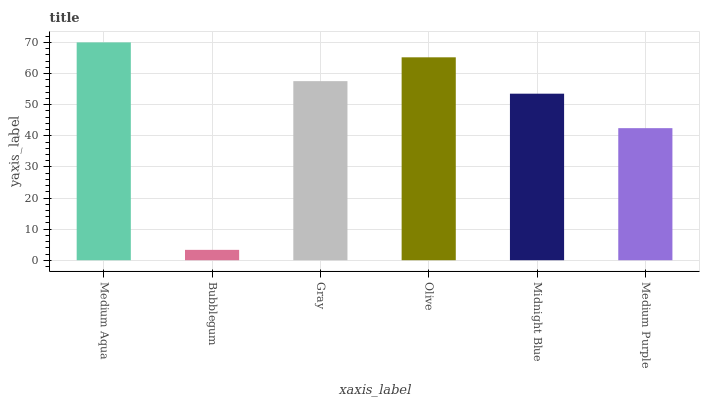Is Bubblegum the minimum?
Answer yes or no. Yes. Is Medium Aqua the maximum?
Answer yes or no. Yes. Is Gray the minimum?
Answer yes or no. No. Is Gray the maximum?
Answer yes or no. No. Is Gray greater than Bubblegum?
Answer yes or no. Yes. Is Bubblegum less than Gray?
Answer yes or no. Yes. Is Bubblegum greater than Gray?
Answer yes or no. No. Is Gray less than Bubblegum?
Answer yes or no. No. Is Gray the high median?
Answer yes or no. Yes. Is Midnight Blue the low median?
Answer yes or no. Yes. Is Bubblegum the high median?
Answer yes or no. No. Is Olive the low median?
Answer yes or no. No. 